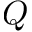Convert formula to latex. <formula><loc_0><loc_0><loc_500><loc_500>Q</formula> 